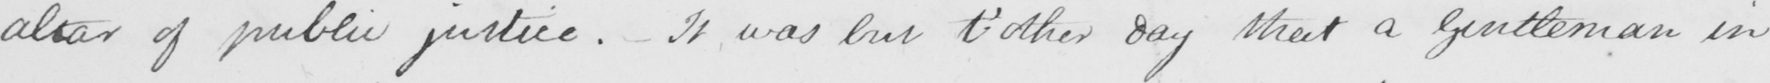What is written in this line of handwriting? altar of public justice . It was but t ' other day that a gentleman in 